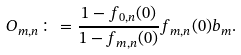Convert formula to latex. <formula><loc_0><loc_0><loc_500><loc_500>O _ { m , n } \colon = \frac { 1 - f _ { 0 , n } ( 0 ) } { 1 - f _ { m , n } ( 0 ) } f _ { m , n } ( 0 ) b _ { m } .</formula> 